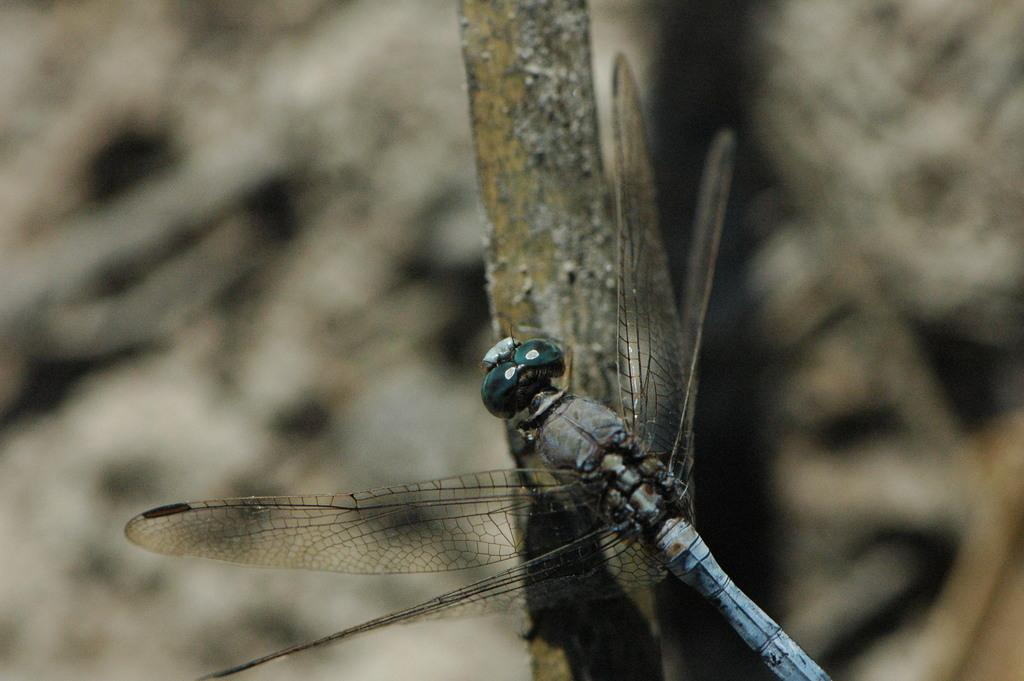What is the main subject of the image? The main subject of the image is a dragonfly. Where is the dragonfly located in the image? The dragonfly is on a stem. What can be observed about the background of the image? The background of the image is blurred. How does the dragonfly twist around the stem in the image? The image does not show the dragonfly twisting around the stem; it is stationary on the stem. What type of payment is required to view the dragonfly in the image? There is no payment required to view the dragonfly in the image; it is freely visible. 